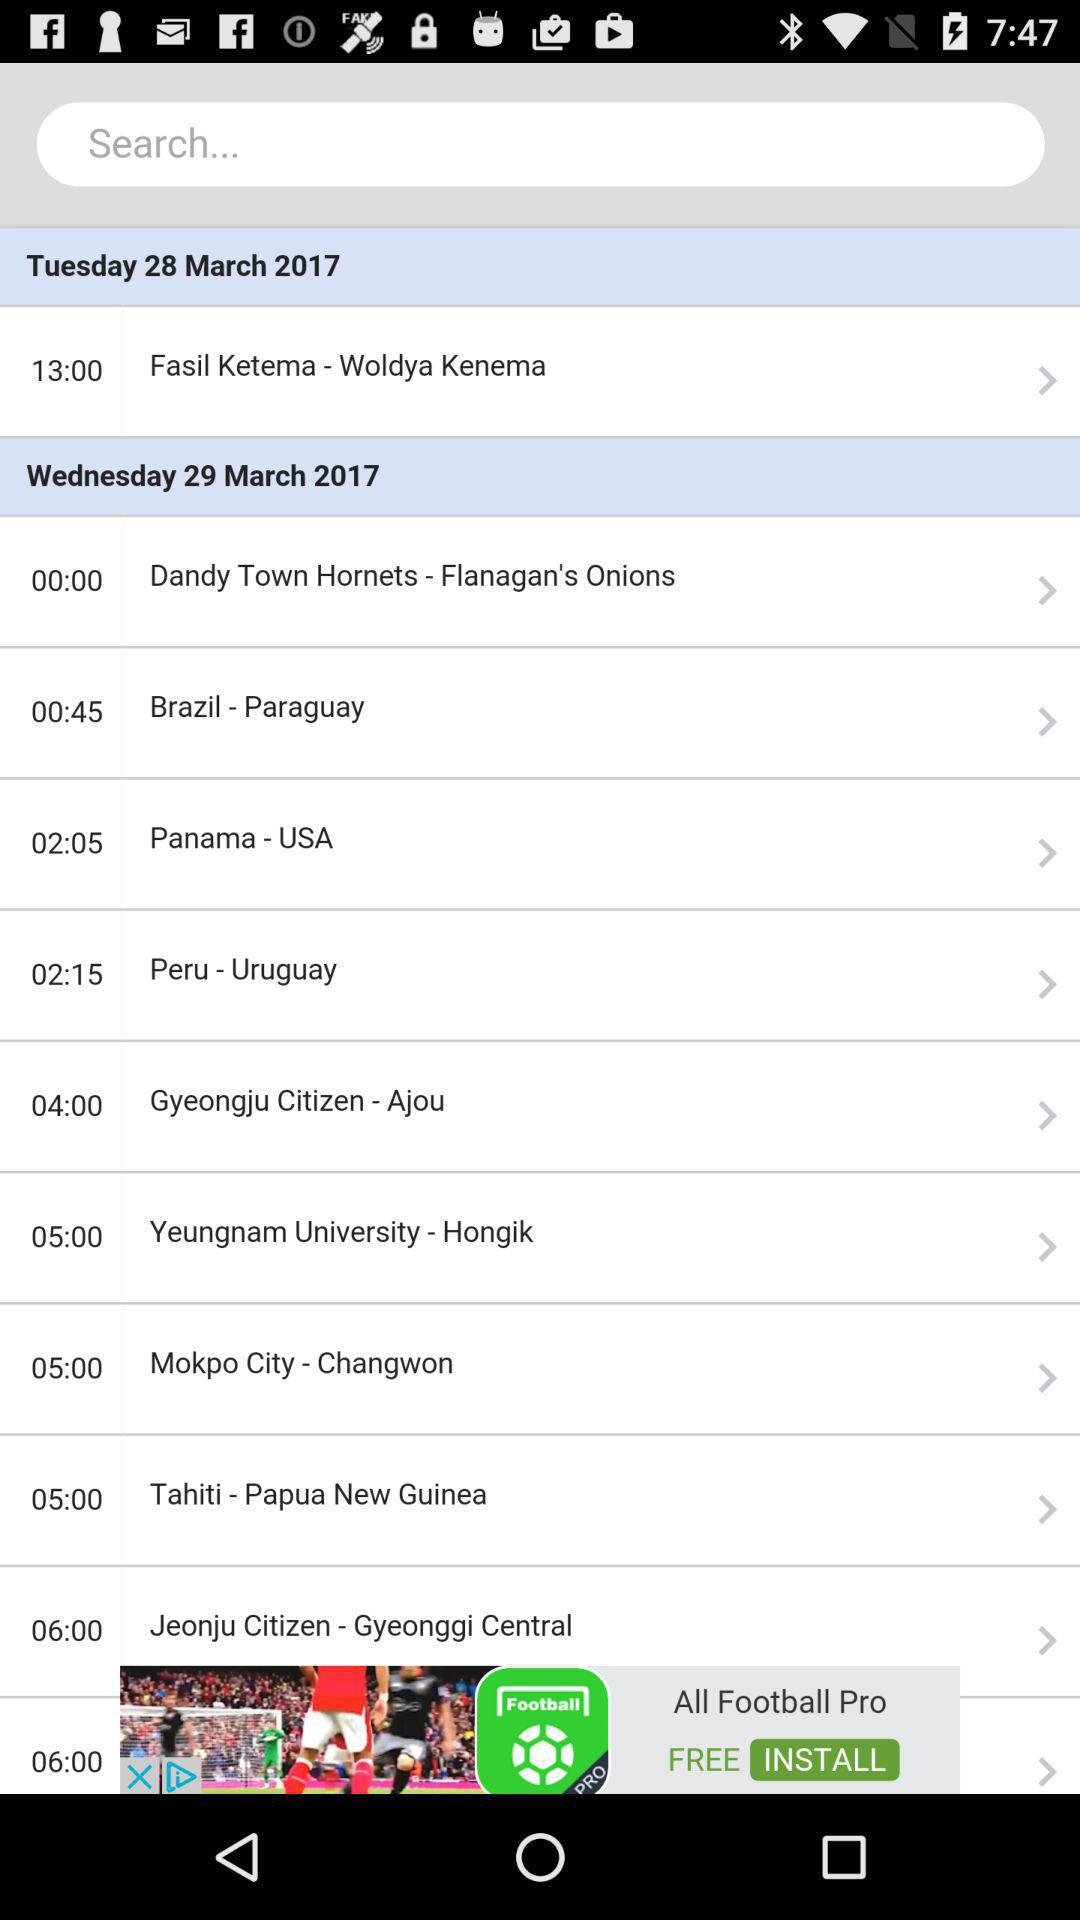What is the selected date for "Fasil ketema - Woldya Kenema"? The selected date is Tuesday, March 28, 2017. 